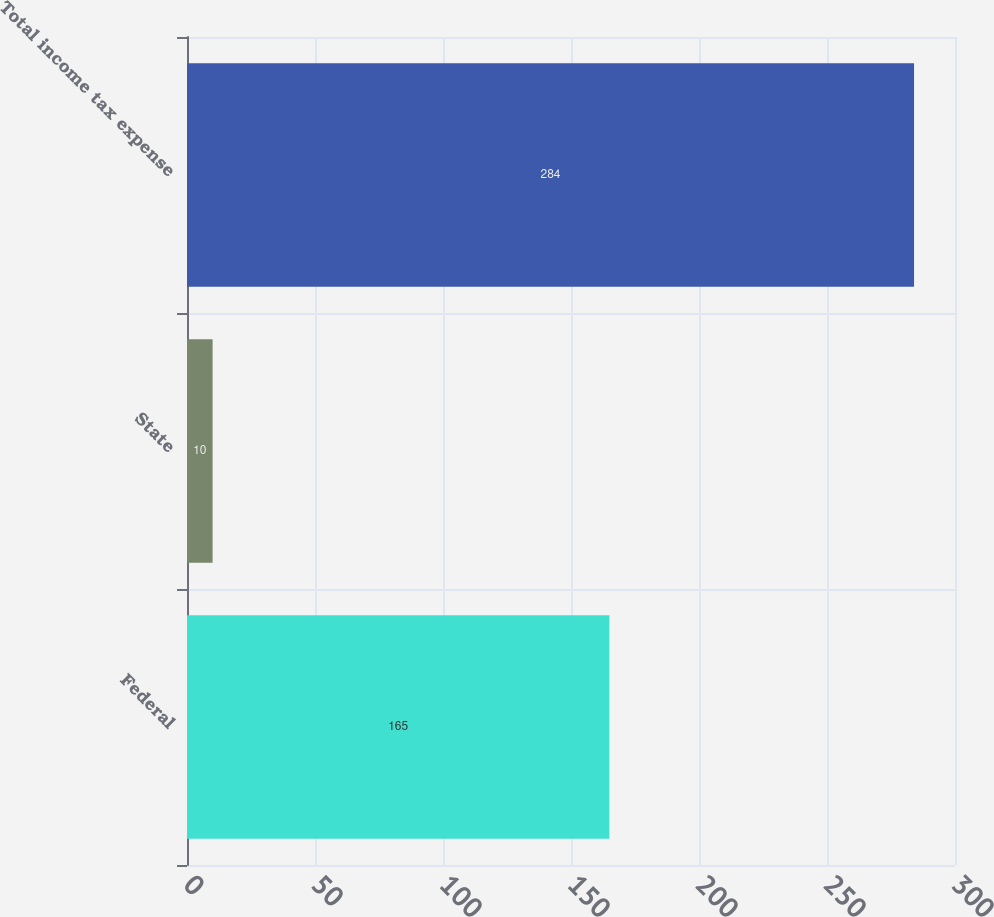<chart> <loc_0><loc_0><loc_500><loc_500><bar_chart><fcel>Federal<fcel>State<fcel>Total income tax expense<nl><fcel>165<fcel>10<fcel>284<nl></chart> 